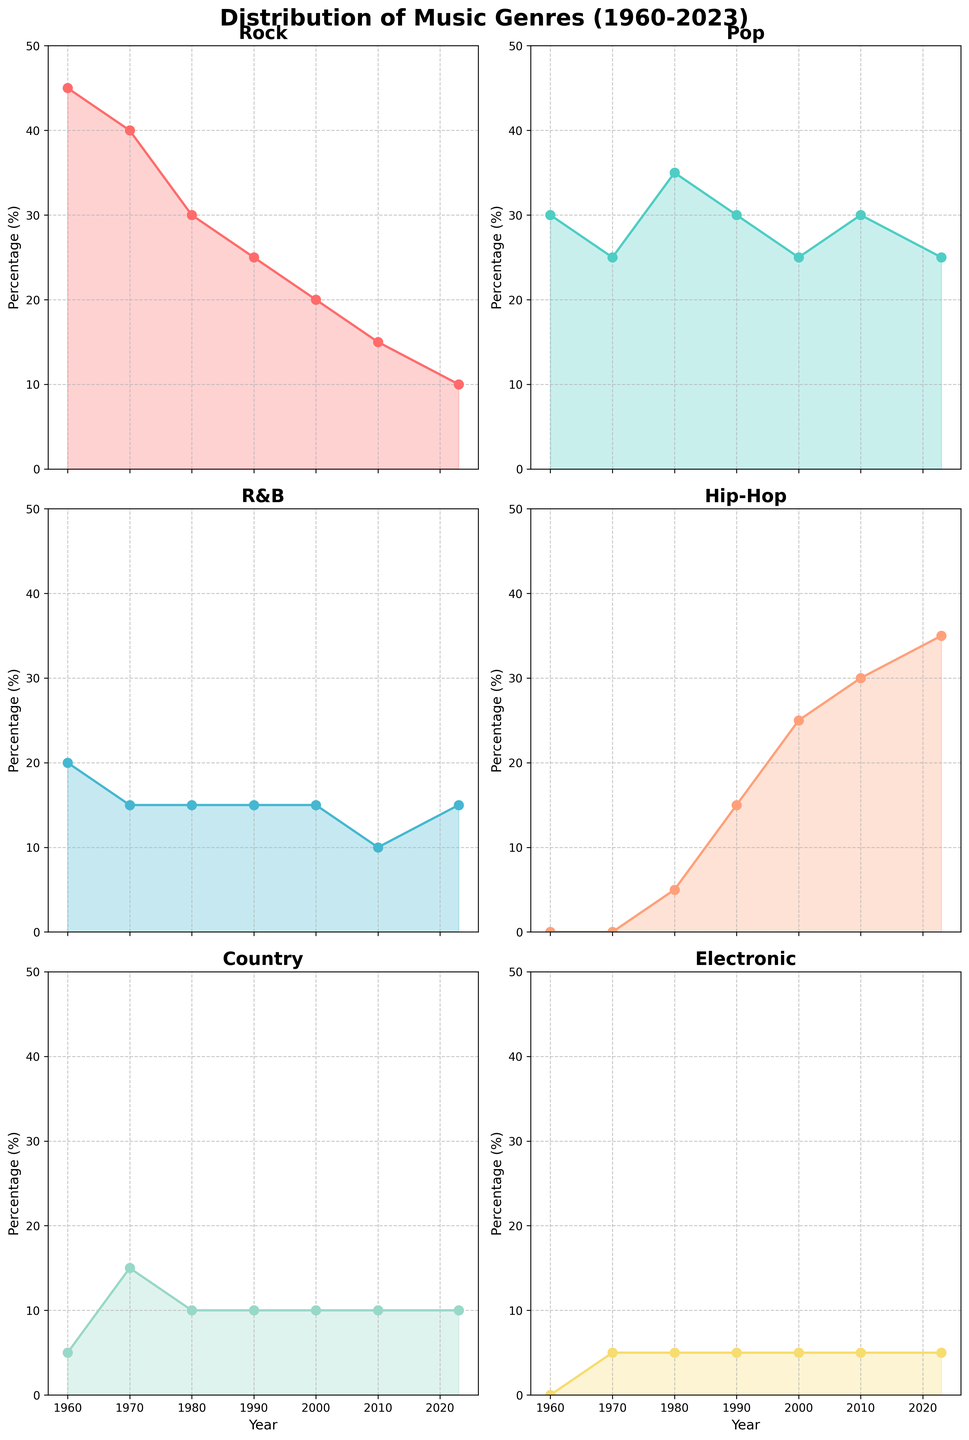What title is displayed at the top of the figure? The title at the top of the figure is given in bold and large font, indicating the subject of the data visualization. The title helps viewers immediately understand what the figure is about.
Answer: Distribution of Music Genres (1960-2023) Which genre shows the highest percentage in the year 1960? By examining the 1960 data points in each subplot, one can determine which genre has the highest percentage in that year.
Answer: Rock How did the percentage of Hip-Hop change from 1990 to 2023? Locate the Hip-Hop subplot and compare the data points from the year 1990 to 2023. Calculate the difference to understand the trend over these years.
Answer: Increased by 20% Which genre had a constant percentage from 1960 to 2023? By examining each genre's subplot, identify any genre that maintains a flat line or constant percentage throughout all the years.
Answer: Electronic In which decade did Pop surpass Rock in percentage for the first time? Check the Pop and Rock subplots and identify the time frame where Pop's percentage first exceeds Rock's. This would require a point-by-point comparison over the decades.
Answer: 1980s What is the average percentage of Country music from 1960 to 2023? Collect the percentage values of Country music for all the years, sum them up, and divide by the number of years.
Answer: 10% Between 2000 and 2010, which genre experienced the largest increase in percentage? Compare the percentage values for each genre between 2000 and 2010. Calculate the difference and identify the largest increase.
Answer: Hip-Hop Which two genres show a decreasing trend over the years? By examining each genre's subplot, identify two genres that show a downward trend from 1960 to 2023.
Answer: Rock, R&B In what year did R&B reach its lowest percentage? Examine the subplot for R&B and identify the year where the percentage is the lowest.
Answer: 2010 How does the trend of Electronic music differ from other genres? Review the plot for Electronic and compare its trend with the trends of the other genres. Identify distinctive characteristics or behaviors.
Answer: Remains relatively constant 